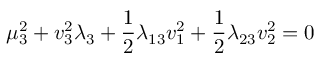<formula> <loc_0><loc_0><loc_500><loc_500>\mu _ { 3 } ^ { 2 } + v _ { 3 } ^ { 2 } \lambda _ { 3 } + \frac { 1 } { 2 } \lambda _ { 1 3 } v _ { 1 } ^ { 2 } + \frac { 1 } { 2 } \lambda _ { 2 3 } v _ { 2 } ^ { 2 } = 0</formula> 